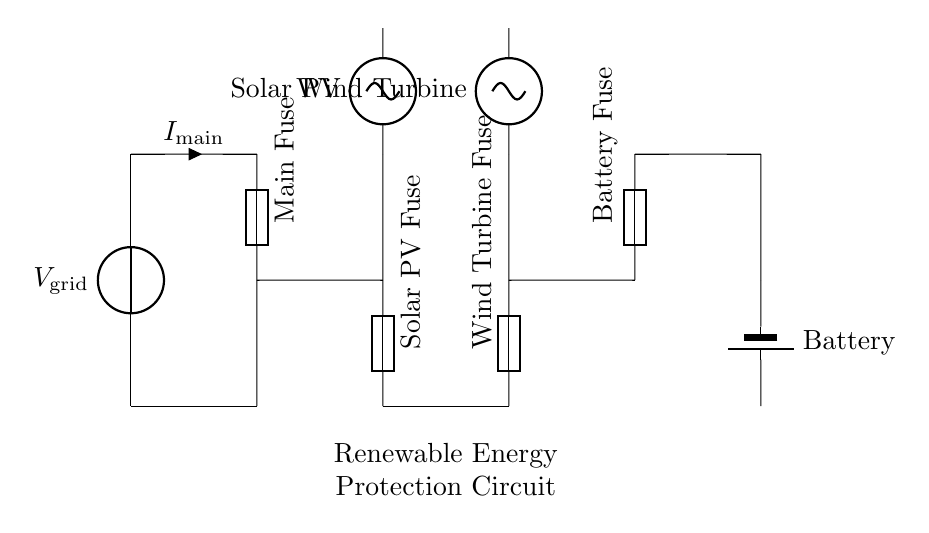What is the main source voltage in the circuit? The main source voltage is indicated as \( V_\text{grid} \) at the top of the circuit. This is typically the voltage supplied by the electrical grid to which the renewable energy system is connected.
Answer: V_grid How many fuses are present in the circuit? The circuit diagram shows four distinct fuses: Main Fuse, Solar PV Fuse, Wind Turbine Fuse, and Battery Fuse. Each fuse protects a different component of the system.
Answer: Four What is the purpose of the Main Fuse? The Main Fuse serves as a protective device for the entire circuit, ensuring that if there's an excess current flowing through the system, it will blow and disconnect the circuit to prevent damage.
Answer: Protection Which renewable energy sources are shown in the circuit? The circuit diagram includes Solar PV and Wind Turbine as renewable energy sources, which are positioned before their respective fuses. This indicates that they are part of the input to the protection circuit.
Answer: Solar PV, Wind Turbine If the Solar PV system experiences a fault causing a surge in current, what happens? If there is a fault causing a surge in current, the Solar PV Fuse will blow, effectively disconnecting the Solar PV system from the rest of the circuit. This helps to protect both the solar panel and other connected components from damage due to overcurrent.
Answer: Solar PV Fuse blows What type of circuit is depicted here? The circuit is a protection circuit designed for grid-connected renewable energy systems, specifically demonstrating how fuses are arranged in series to protect from overcurrent scenarios while allowing multiple energy sources to connect to the grid.
Answer: Protection circuit 